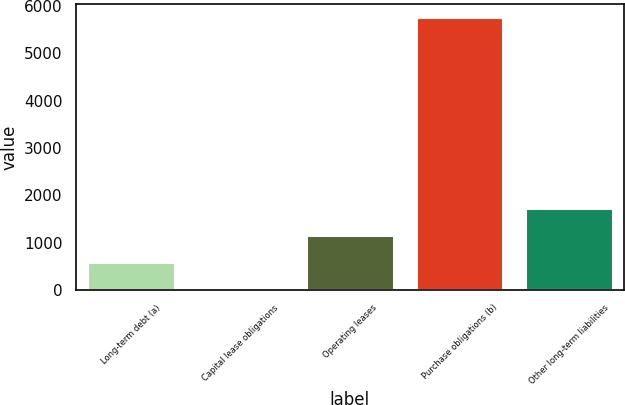<chart> <loc_0><loc_0><loc_500><loc_500><bar_chart><fcel>Long-term debt (a)<fcel>Capital lease obligations<fcel>Operating leases<fcel>Purchase obligations (b)<fcel>Other long-term liabilities<nl><fcel>579.3<fcel>4<fcel>1154.6<fcel>5757<fcel>1729.9<nl></chart> 